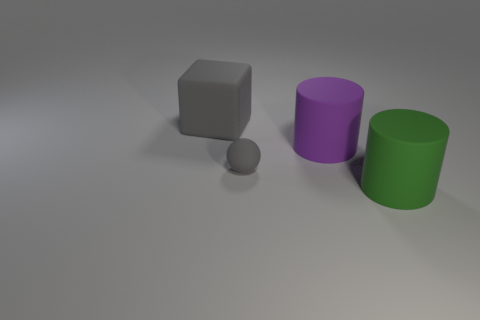Add 2 matte cylinders. How many objects exist? 6 Subtract all blocks. How many objects are left? 3 Subtract 0 blue blocks. How many objects are left? 4 Subtract all big brown objects. Subtract all cubes. How many objects are left? 3 Add 4 large rubber objects. How many large rubber objects are left? 7 Add 1 tiny matte balls. How many tiny matte balls exist? 2 